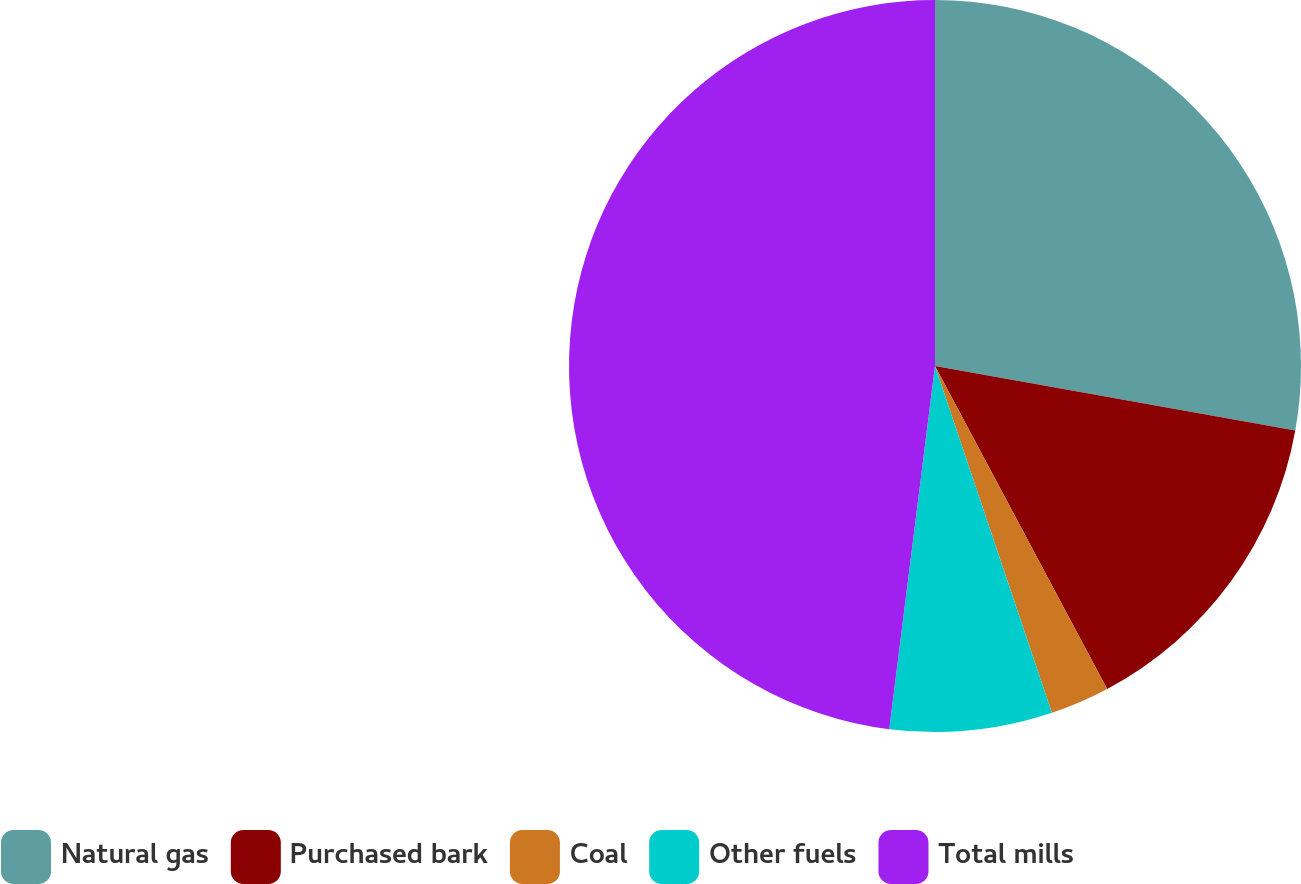Convert chart to OTSL. <chart><loc_0><loc_0><loc_500><loc_500><pie_chart><fcel>Natural gas<fcel>Purchased bark<fcel>Coal<fcel>Other fuels<fcel>Total mills<nl><fcel>27.82%<fcel>14.39%<fcel>2.62%<fcel>7.17%<fcel>48.01%<nl></chart> 